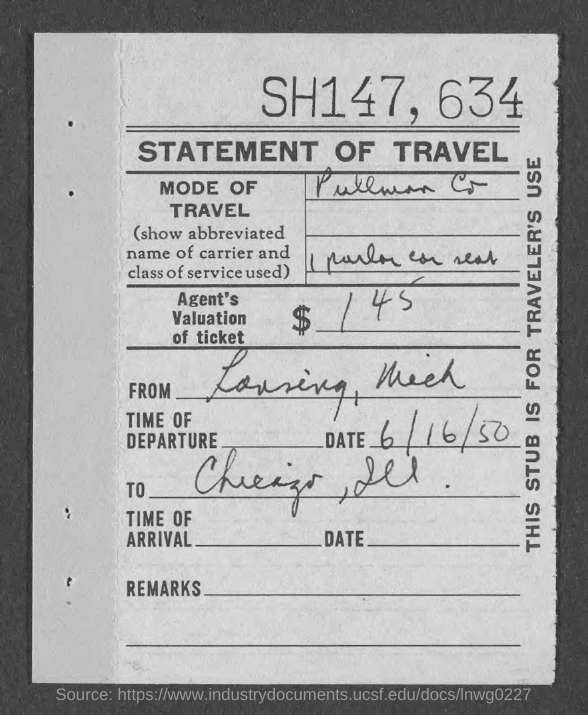What is the Title of the document?
Provide a short and direct response. STATEMENT OF TRAVEL. What is the mode of travel?
Your answer should be very brief. Pullman Co. What is the date of departure?
Give a very brief answer. 6/16/50. What is this stub for?
Your response must be concise. TRAVELER'S USE. 